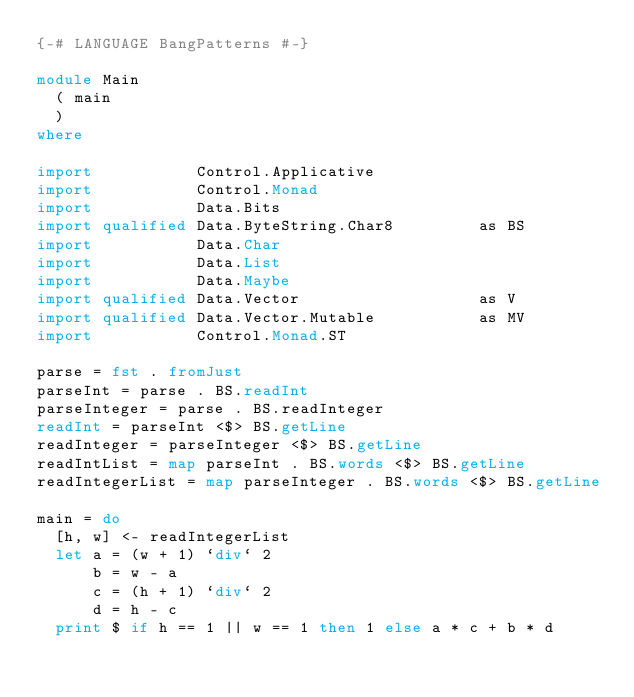Convert code to text. <code><loc_0><loc_0><loc_500><loc_500><_Haskell_>{-# LANGUAGE BangPatterns #-}
 
module Main
  ( main
  )
where
 
import           Control.Applicative
import           Control.Monad
import           Data.Bits
import qualified Data.ByteString.Char8         as BS
import           Data.Char
import           Data.List
import           Data.Maybe
import qualified Data.Vector                   as V
import qualified Data.Vector.Mutable           as MV
import           Control.Monad.ST
 
parse = fst . fromJust
parseInt = parse . BS.readInt
parseInteger = parse . BS.readInteger
readInt = parseInt <$> BS.getLine
readInteger = parseInteger <$> BS.getLine
readIntList = map parseInt . BS.words <$> BS.getLine
readIntegerList = map parseInteger . BS.words <$> BS.getLine
 
main = do
  [h, w] <- readIntegerList
  let a = (w + 1) `div` 2
      b = w - a
      c = (h + 1) `div` 2
      d = h - c
  print $ if h == 1 || w == 1 then 1 else a * c + b * d</code> 